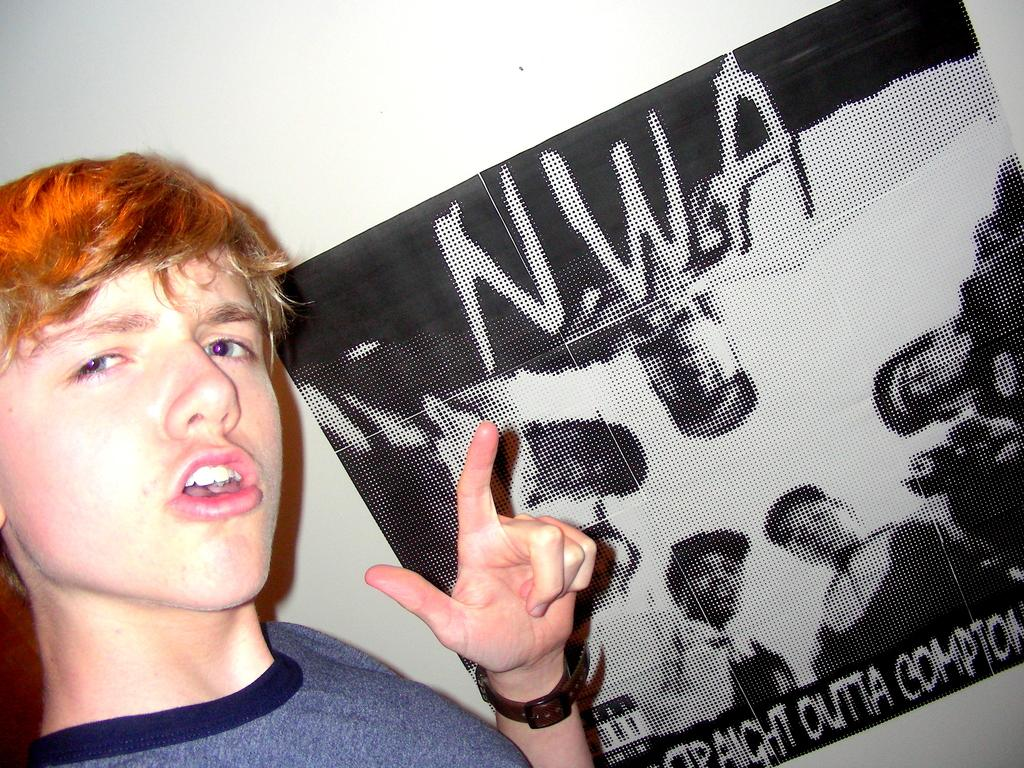What is present in the image? There is a man and an advertisement in the image. Can you describe the man in the image? The facts provided do not give any specific details about the man's appearance or actions. What type of advertisement is visible in the image? The facts provided do not give any specific details about the advertisement. How many cups are on the calendar in the image? There is no mention of cups or a calendar in the image. 